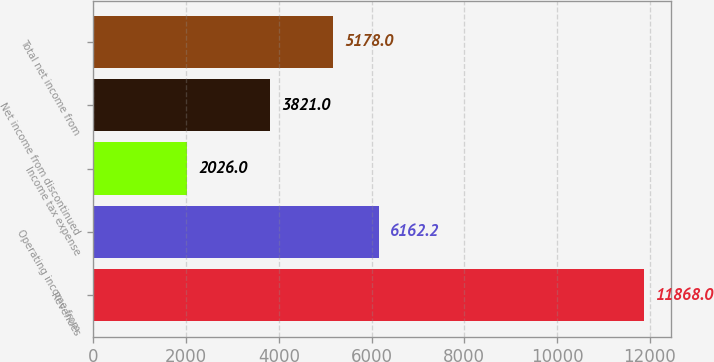Convert chart. <chart><loc_0><loc_0><loc_500><loc_500><bar_chart><fcel>Revenues<fcel>Operating income from<fcel>Income tax expense<fcel>Net income from discontinued<fcel>Total net income from<nl><fcel>11868<fcel>6162.2<fcel>2026<fcel>3821<fcel>5178<nl></chart> 